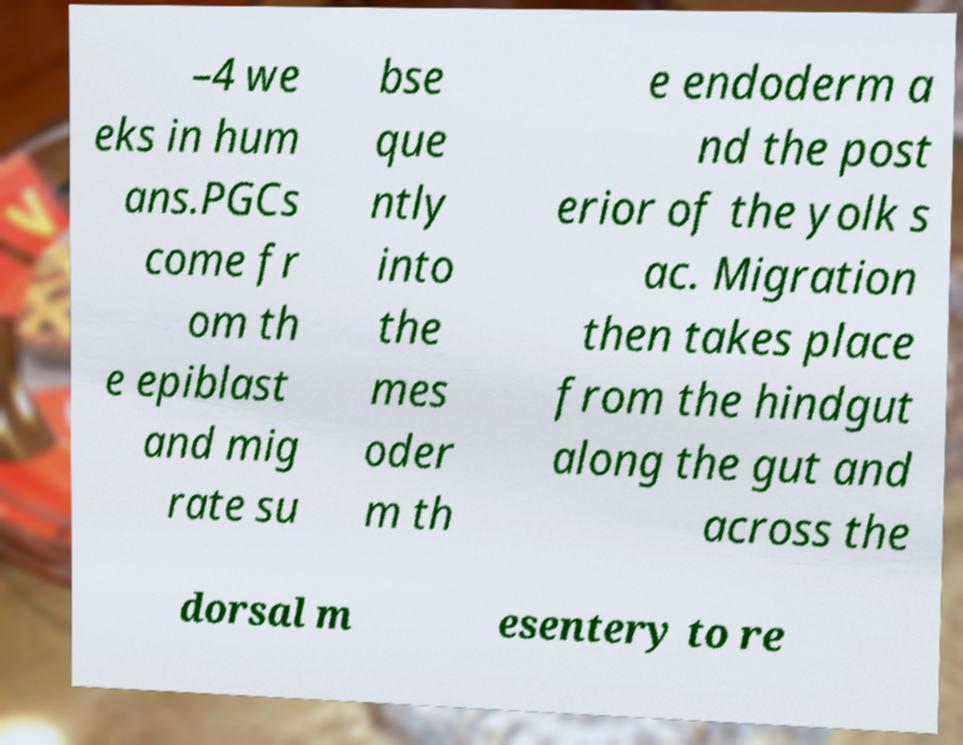What messages or text are displayed in this image? I need them in a readable, typed format. –4 we eks in hum ans.PGCs come fr om th e epiblast and mig rate su bse que ntly into the mes oder m th e endoderm a nd the post erior of the yolk s ac. Migration then takes place from the hindgut along the gut and across the dorsal m esentery to re 